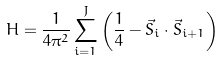Convert formula to latex. <formula><loc_0><loc_0><loc_500><loc_500>H = \frac { 1 } { 4 \pi ^ { 2 } } \sum _ { i = 1 } ^ { J } \left ( \frac { 1 } { 4 } - \vec { S } _ { i } \cdot \vec { S } _ { i + 1 } \right )</formula> 